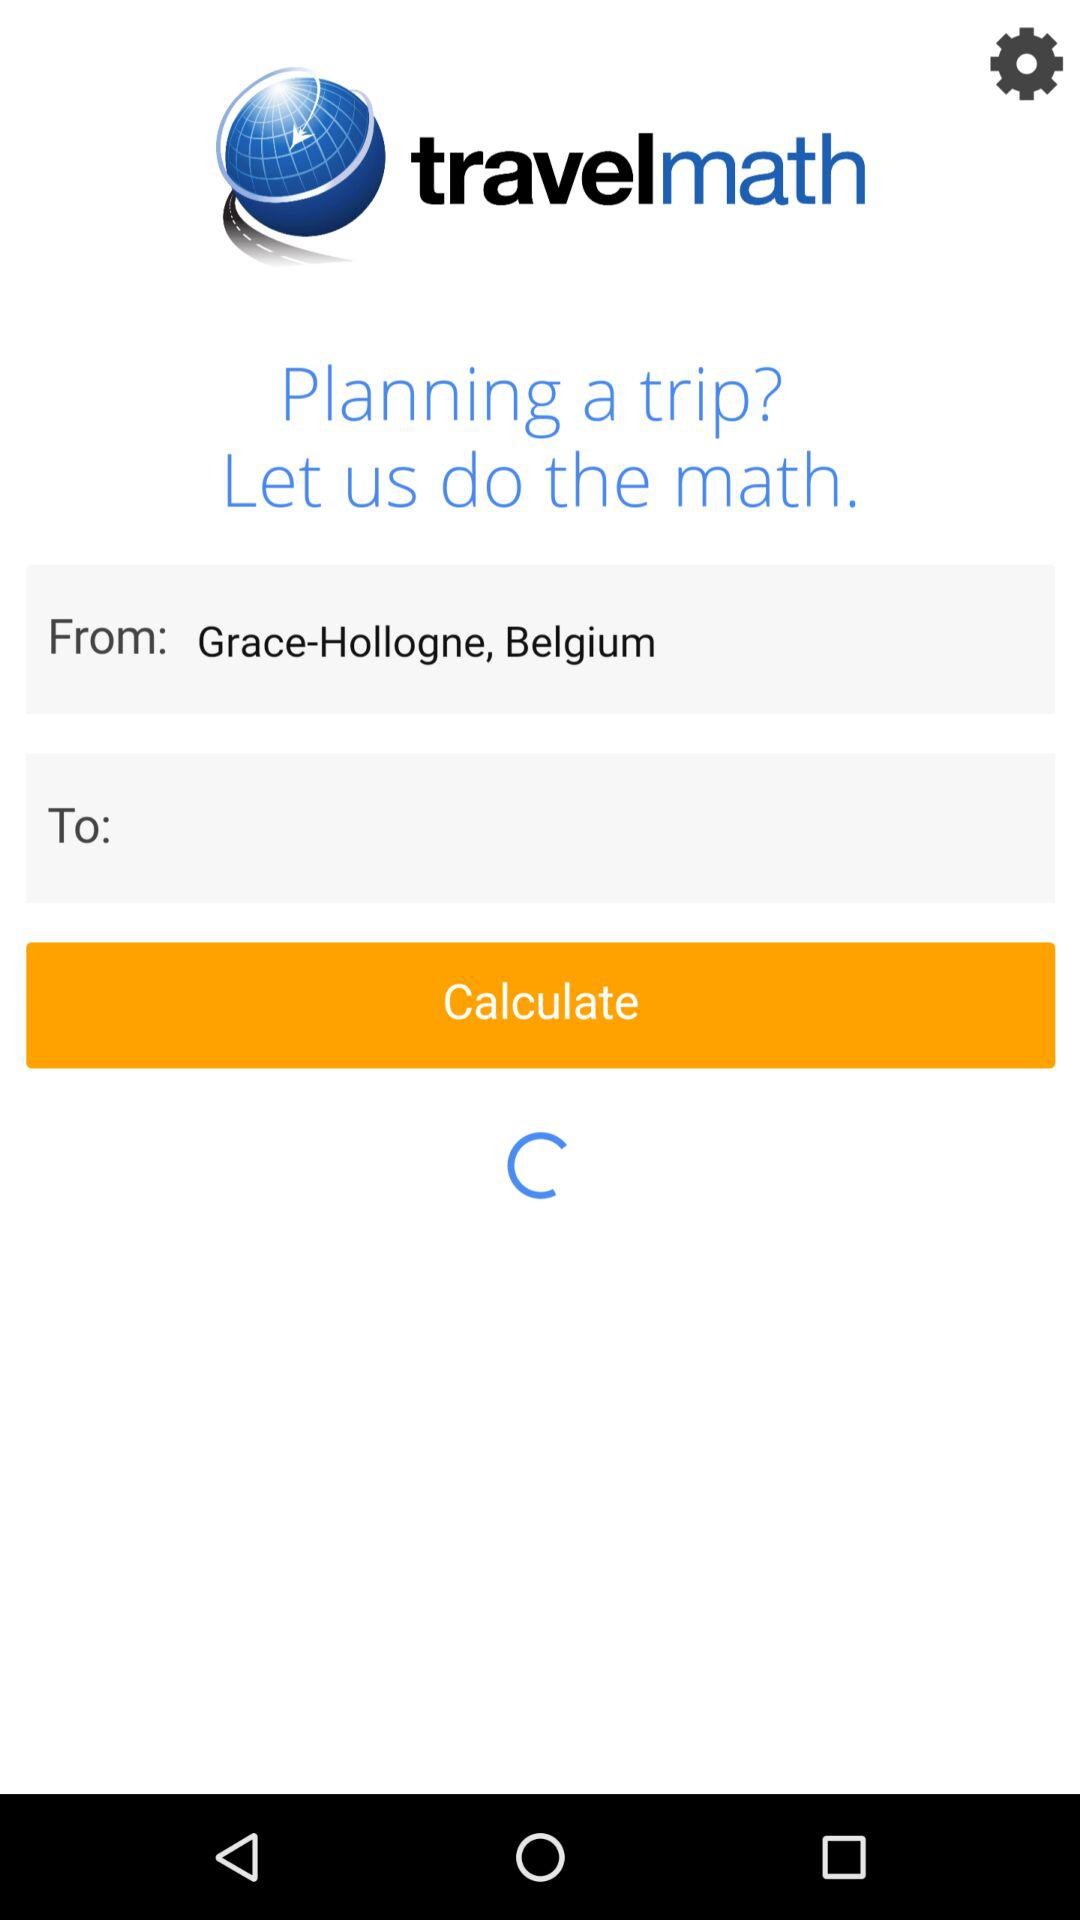Where is it to?
When the provided information is insufficient, respond with <no answer>. <no answer> 